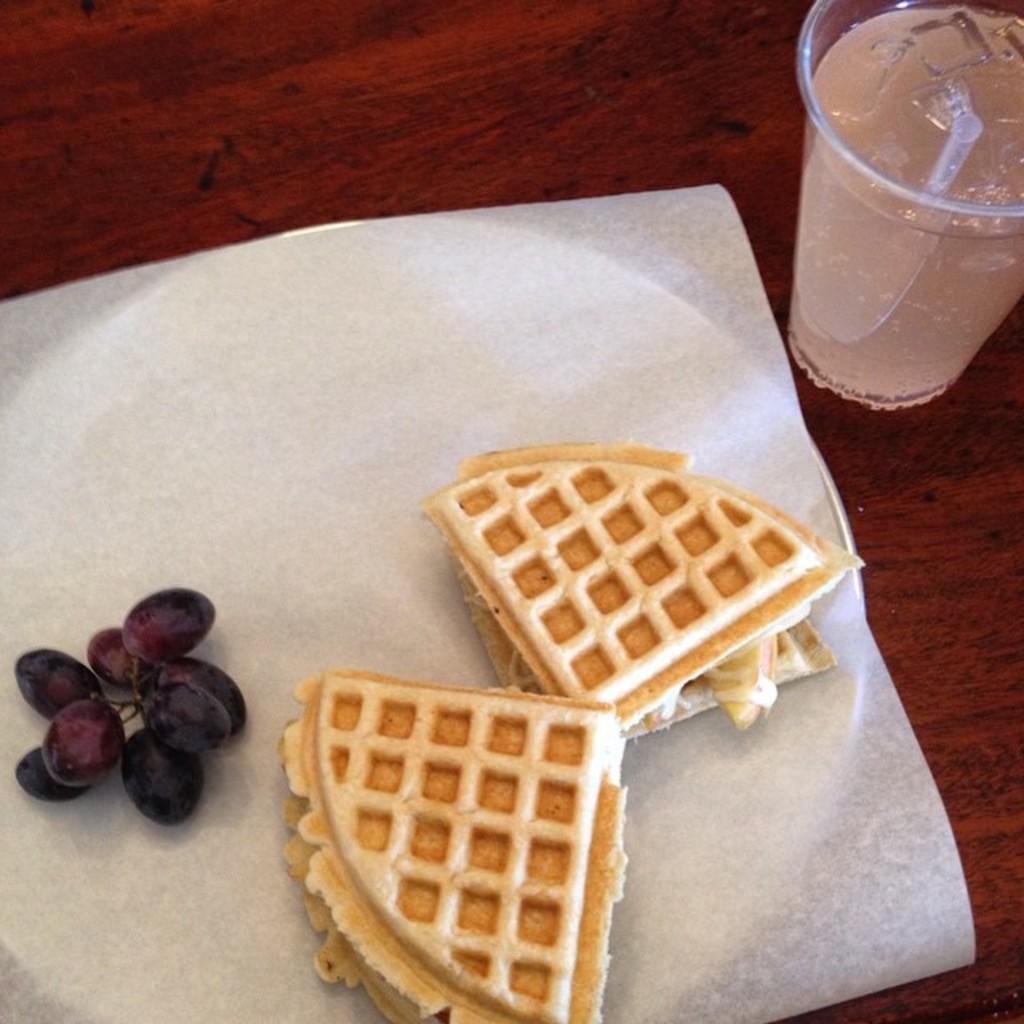Describe this image in one or two sentences. In this image there is a plate and a glass on the table. The glass is filled with the drink. There is a straw in the glass. The plate is covered with the tissue paper. There is some food and fruits are on the plate. 